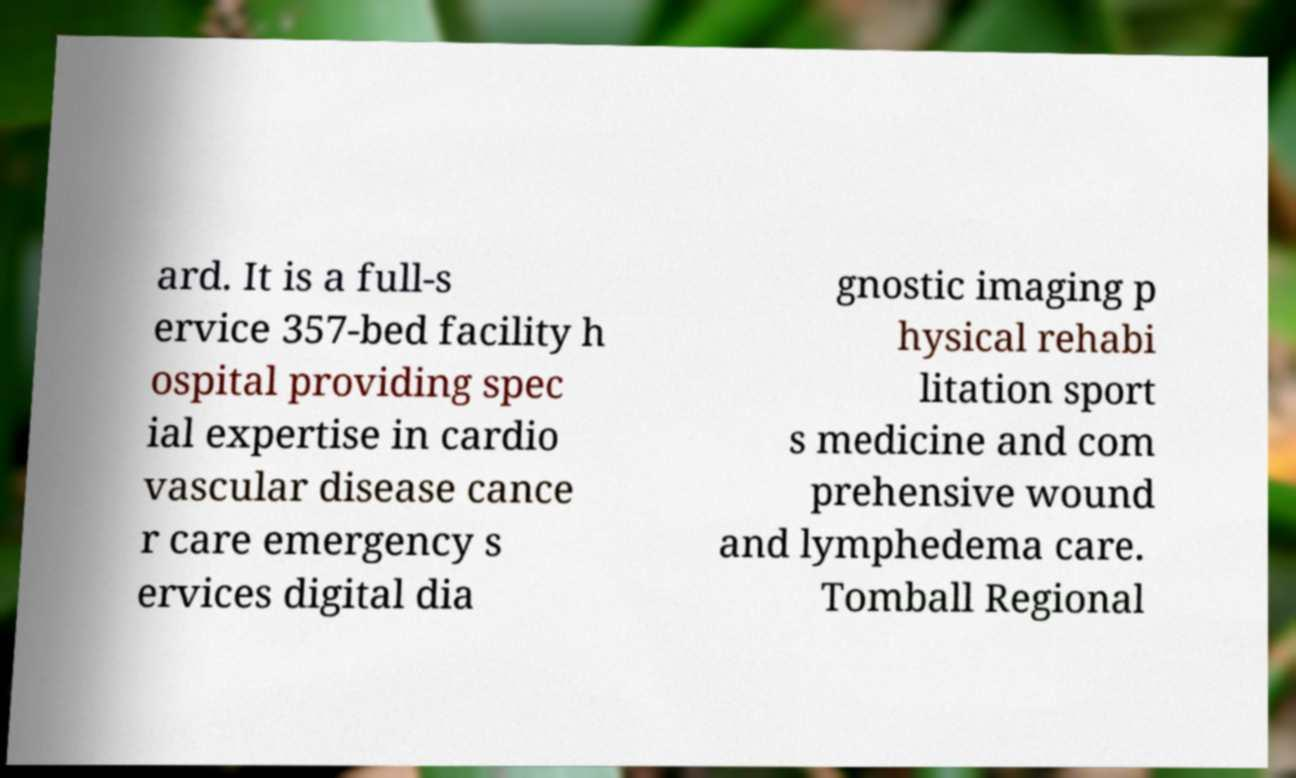Can you accurately transcribe the text from the provided image for me? ard. It is a full-s ervice 357-bed facility h ospital providing spec ial expertise in cardio vascular disease cance r care emergency s ervices digital dia gnostic imaging p hysical rehabi litation sport s medicine and com prehensive wound and lymphedema care. Tomball Regional 